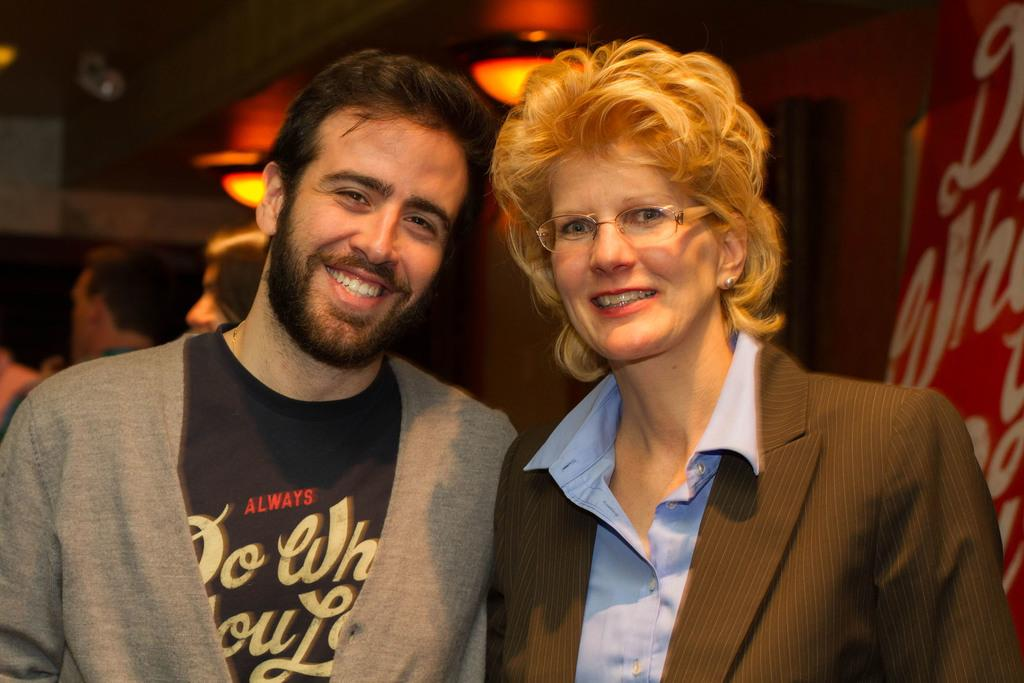How many people are in the image? There are two persons in the image. What are the persons wearing? The persons are wearing clothes. What can be seen at the top of the image? There are lights at the top of the image. Can you tell me how many baseballs are being touched by the persons in the image? There is no baseball present in the image, so it is not possible to determine how many baseballs are being touched. 